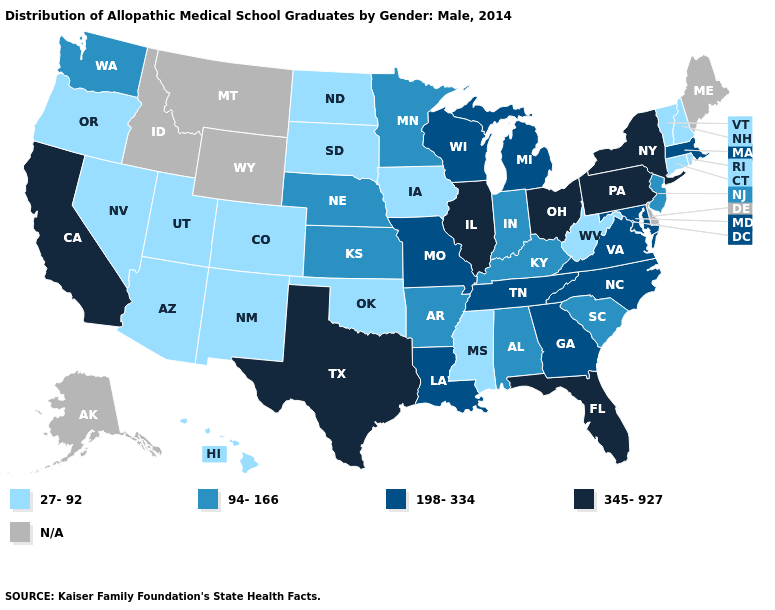Which states have the lowest value in the West?
Give a very brief answer. Arizona, Colorado, Hawaii, Nevada, New Mexico, Oregon, Utah. Name the states that have a value in the range N/A?
Be succinct. Alaska, Delaware, Idaho, Maine, Montana, Wyoming. Does the map have missing data?
Be succinct. Yes. What is the lowest value in states that border Virginia?
Quick response, please. 27-92. Which states have the lowest value in the USA?
Write a very short answer. Arizona, Colorado, Connecticut, Hawaii, Iowa, Mississippi, Nevada, New Hampshire, New Mexico, North Dakota, Oklahoma, Oregon, Rhode Island, South Dakota, Utah, Vermont, West Virginia. What is the highest value in states that border Mississippi?
Answer briefly. 198-334. Name the states that have a value in the range N/A?
Quick response, please. Alaska, Delaware, Idaho, Maine, Montana, Wyoming. Does New York have the highest value in the USA?
Concise answer only. Yes. Does Massachusetts have the lowest value in the Northeast?
Give a very brief answer. No. Among the states that border Missouri , which have the highest value?
Keep it brief. Illinois. Does New York have the highest value in the USA?
Be succinct. Yes. What is the value of Rhode Island?
Concise answer only. 27-92. What is the value of Montana?
Answer briefly. N/A. Which states have the highest value in the USA?
Quick response, please. California, Florida, Illinois, New York, Ohio, Pennsylvania, Texas. 